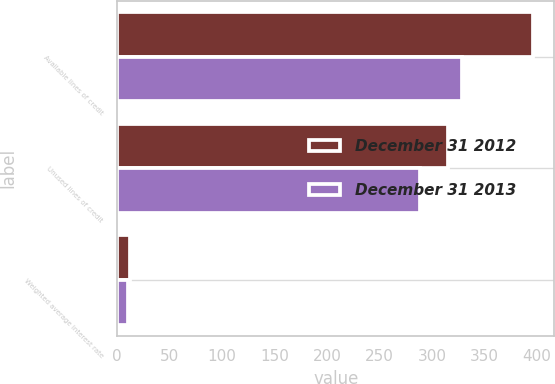<chart> <loc_0><loc_0><loc_500><loc_500><stacked_bar_chart><ecel><fcel>Available lines of credit<fcel>Unused lines of credit<fcel>Weighted average interest rate<nl><fcel>December 31 2012<fcel>396.6<fcel>315<fcel>12.3<nl><fcel>December 31 2013<fcel>328.3<fcel>289<fcel>10.2<nl></chart> 